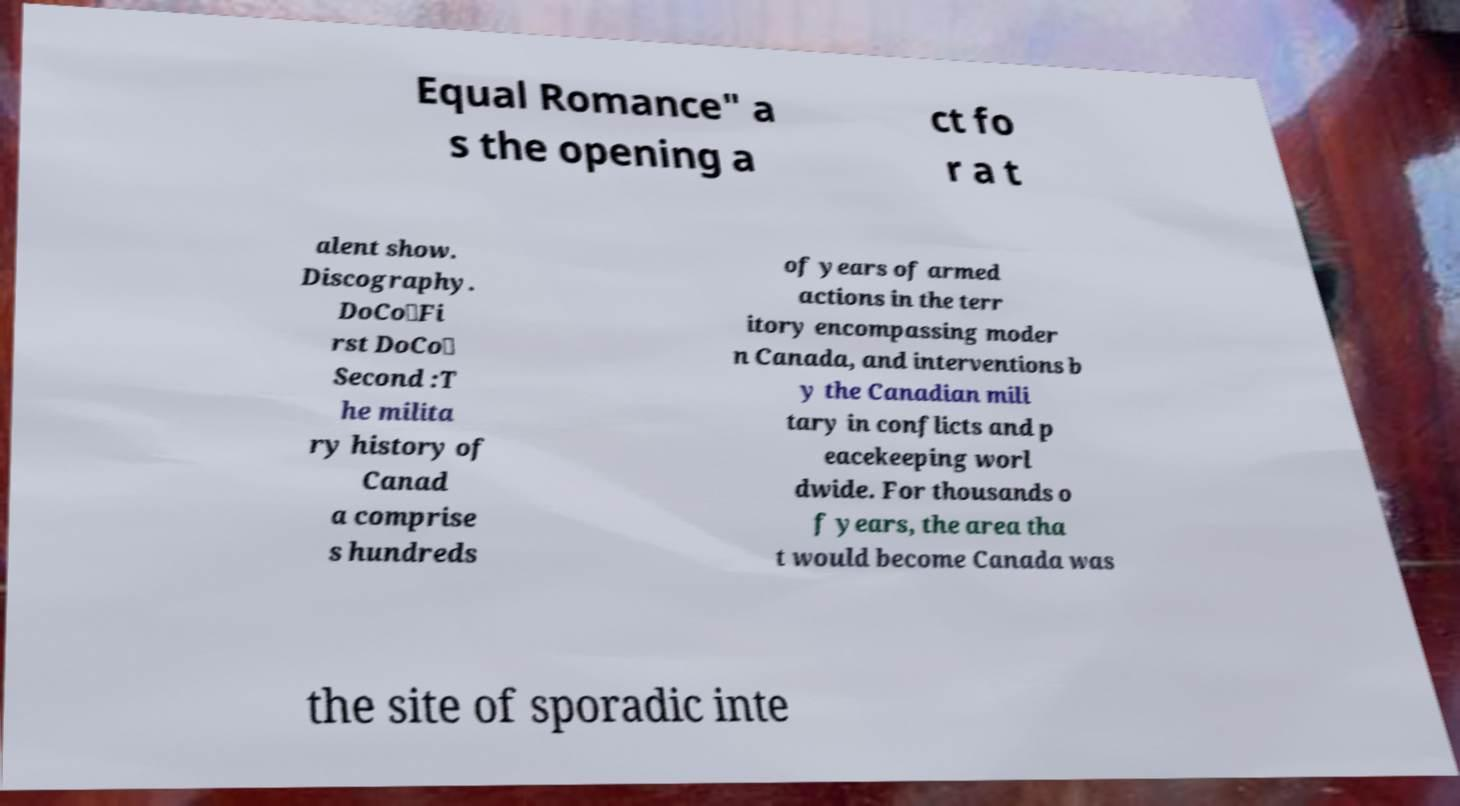Please read and relay the text visible in this image. What does it say? Equal Romance" a s the opening a ct fo r a t alent show. Discography. DoCo★Fi rst DoCo☆ Second :T he milita ry history of Canad a comprise s hundreds of years of armed actions in the terr itory encompassing moder n Canada, and interventions b y the Canadian mili tary in conflicts and p eacekeeping worl dwide. For thousands o f years, the area tha t would become Canada was the site of sporadic inte 